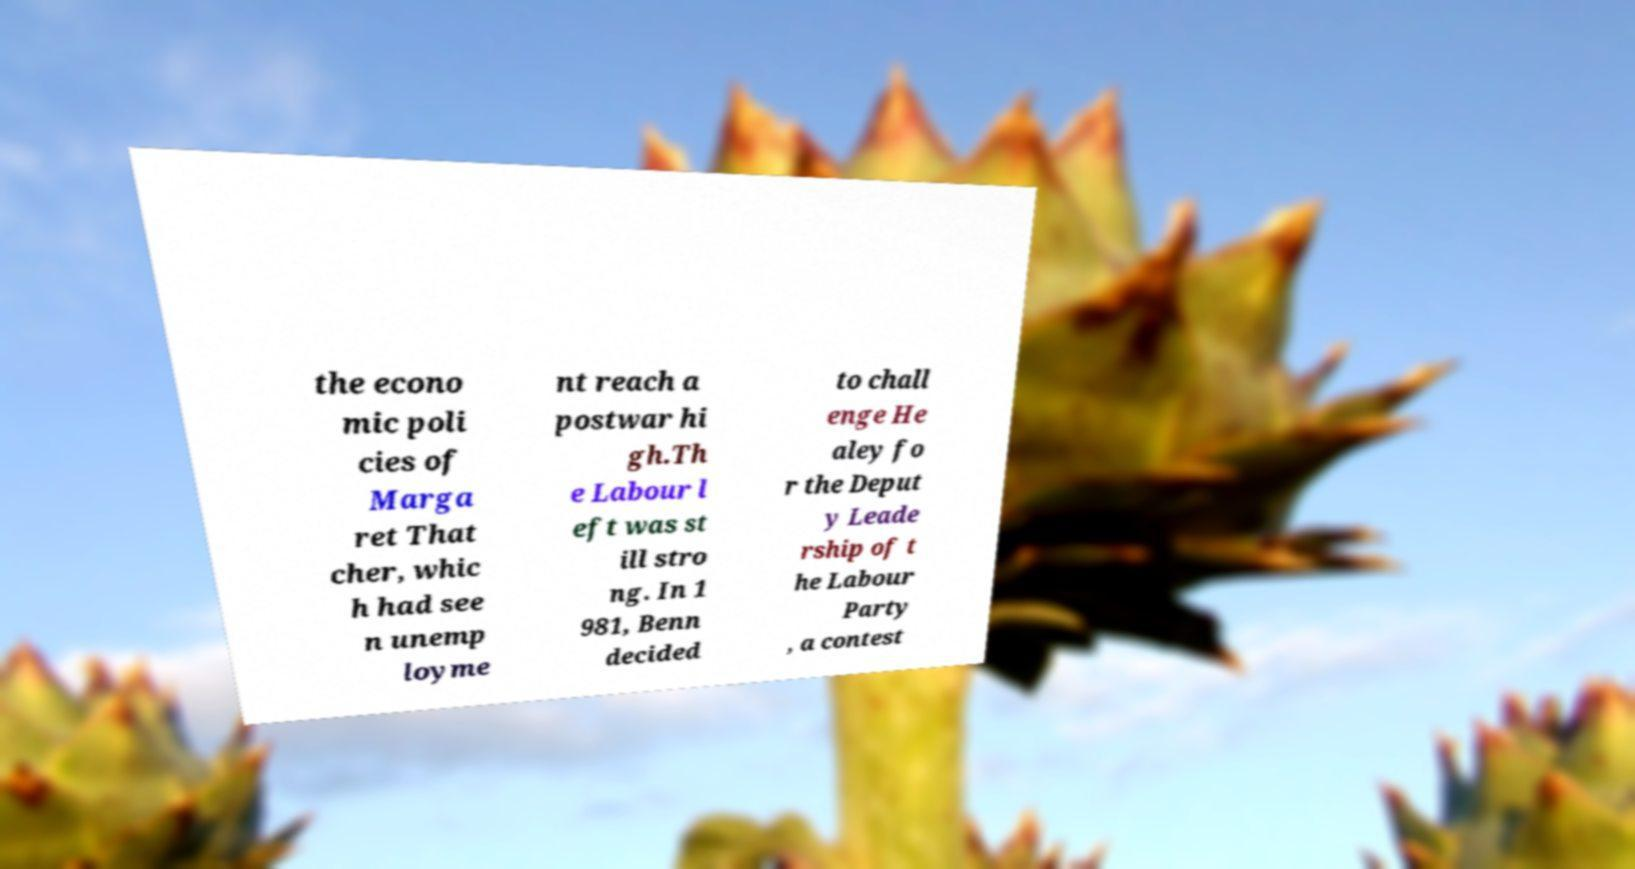I need the written content from this picture converted into text. Can you do that? the econo mic poli cies of Marga ret That cher, whic h had see n unemp loyme nt reach a postwar hi gh.Th e Labour l eft was st ill stro ng. In 1 981, Benn decided to chall enge He aley fo r the Deput y Leade rship of t he Labour Party , a contest 